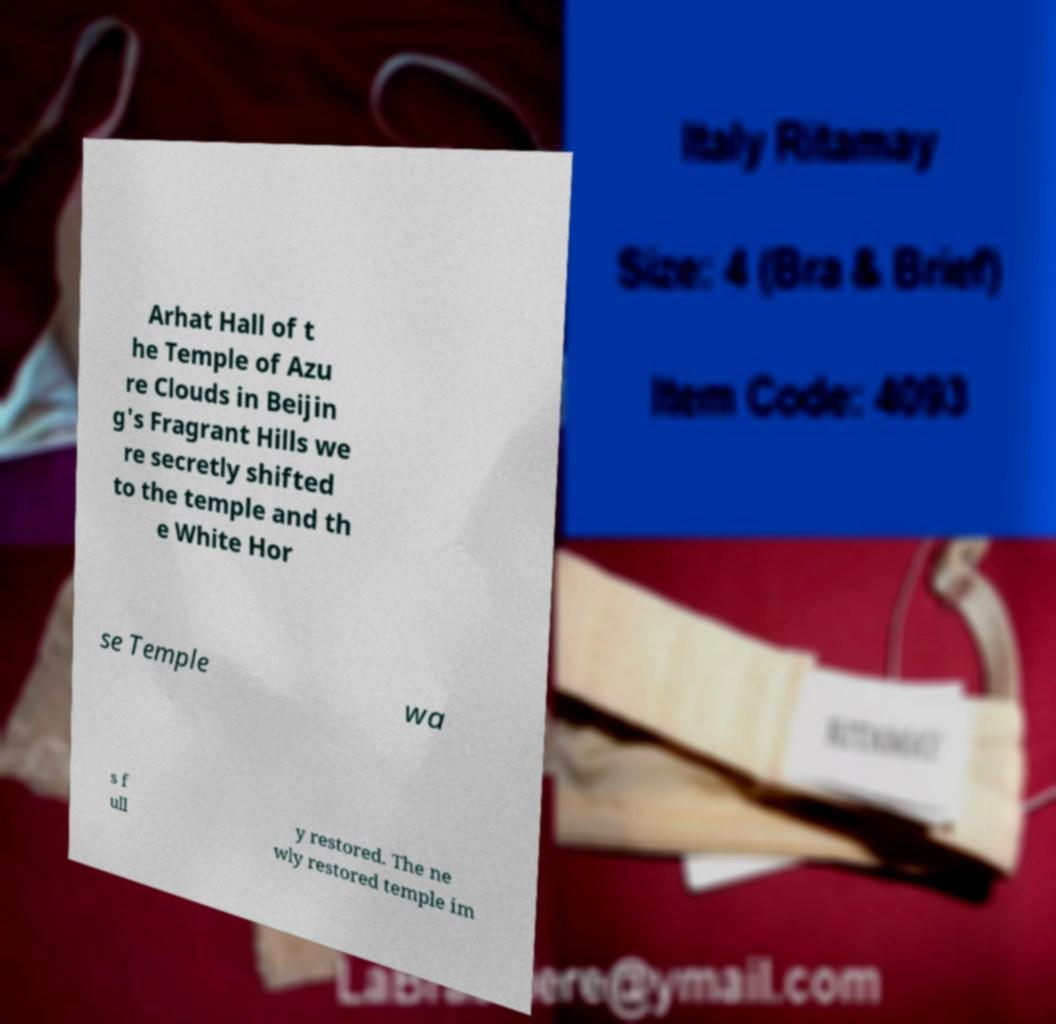Can you accurately transcribe the text from the provided image for me? Arhat Hall of t he Temple of Azu re Clouds in Beijin g's Fragrant Hills we re secretly shifted to the temple and th e White Hor se Temple wa s f ull y restored. The ne wly restored temple im 